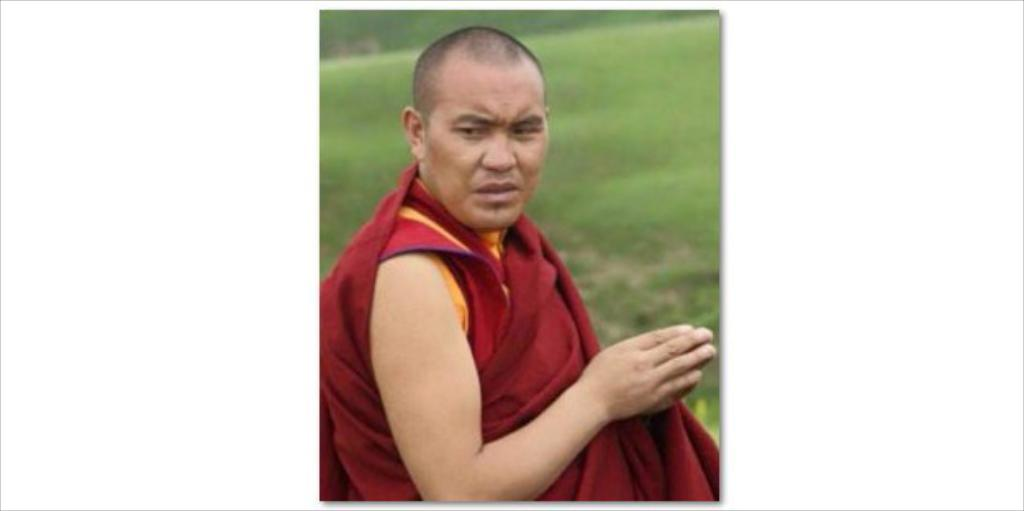Who or what is present in the image? There is a person in the image. What is the person wearing? The person is wearing a maroon color dress. What type of surface can be seen in the image? There is ground visible in the image. What is the condition of the trees in the image? The trees in the image are blurry. What letters can be seen on the person's dress in the image? There are no letters visible on the person's dress in the image. 